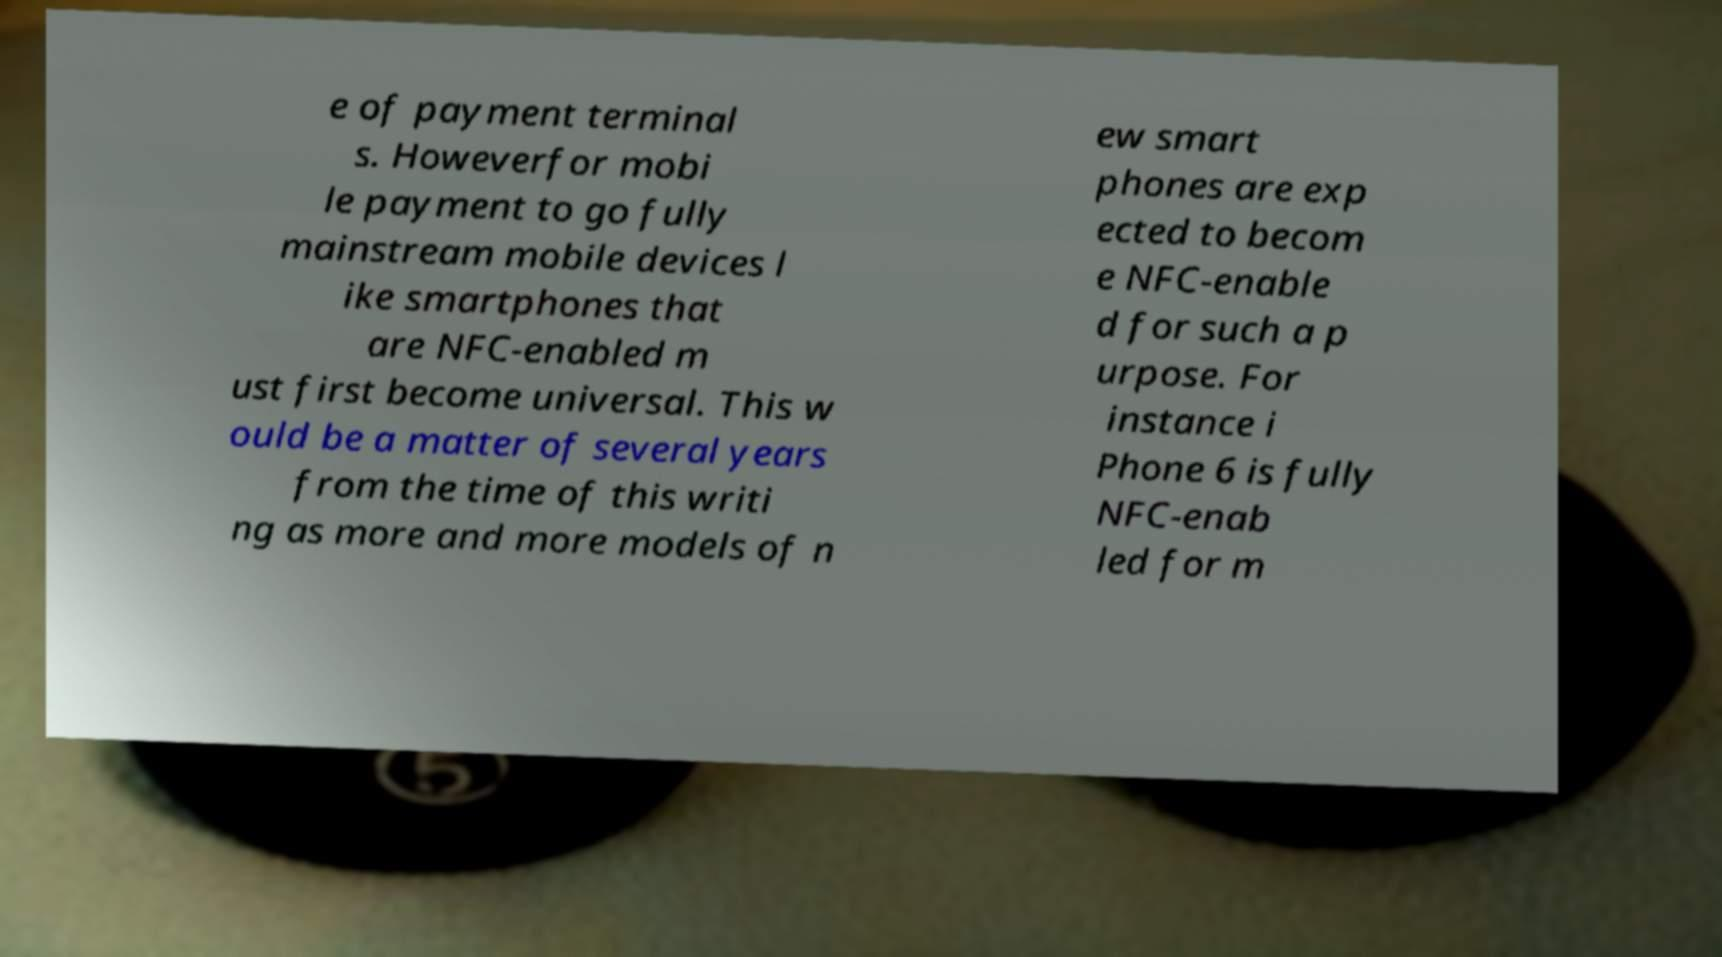Could you extract and type out the text from this image? e of payment terminal s. Howeverfor mobi le payment to go fully mainstream mobile devices l ike smartphones that are NFC-enabled m ust first become universal. This w ould be a matter of several years from the time of this writi ng as more and more models of n ew smart phones are exp ected to becom e NFC-enable d for such a p urpose. For instance i Phone 6 is fully NFC-enab led for m 